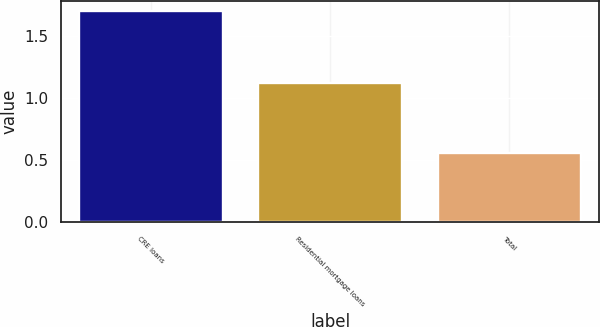<chart> <loc_0><loc_0><loc_500><loc_500><bar_chart><fcel>CRE loans<fcel>Residential mortgage loans<fcel>Total<nl><fcel>1.7<fcel>1.12<fcel>0.56<nl></chart> 